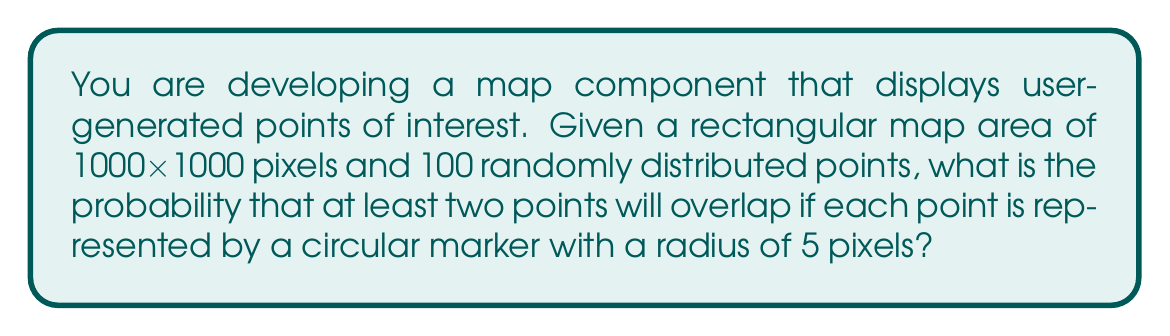Give your solution to this math problem. Let's approach this step-by-step:

1) First, we need to calculate the area of the map and the area of each marker:
   Map area: $A_m = 1000 \times 1000 = 1,000,000$ pixels²
   Marker area: $A_p = \pi r^2 = \pi \times 5^2 \approx 78.54$ pixels²

2) The probability of a single point not overlapping with another can be calculated using the complement of the area occupied by all other points:
   $P(\text{no overlap for one point}) = (1 - \frac{99 \times 78.54}{1,000,000})$

3) For all 100 points to not overlap, this needs to be true for each point independently:
   $P(\text{no overlaps}) = (1 - \frac{99 \times 78.54}{1,000,000})^{100}$

4) Therefore, the probability of at least one overlap is the complement of this:
   $P(\text{at least one overlap}) = 1 - (1 - \frac{99 \times 78.54}{1,000,000})^{100}$

5) Let's calculate this:
   $P(\text{at least one overlap}) = 1 - (1 - \frac{7775.46}{1,000,000})^{100}$
   $= 1 - (0.9922245)^{100}$
   $= 1 - 0.4611$
   $= 0.5389$

6) Converting to a percentage:
   $0.5389 \times 100\% = 53.89\%$
Answer: 53.89% 